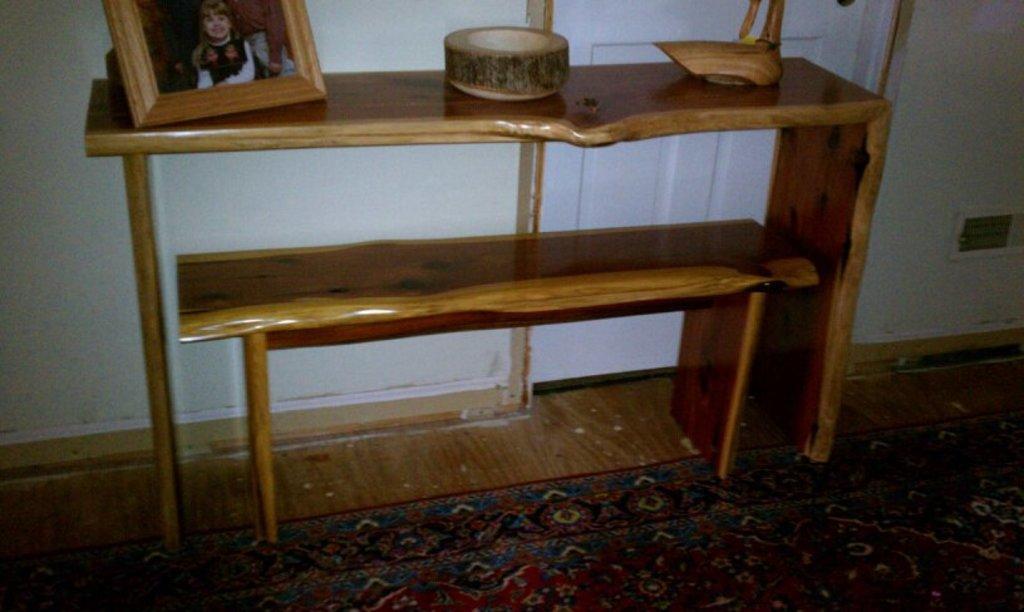Could you give a brief overview of what you see in this image? In this image we can see a wooden table on which a photo frame and few things are placed. in the background we can see a door. 